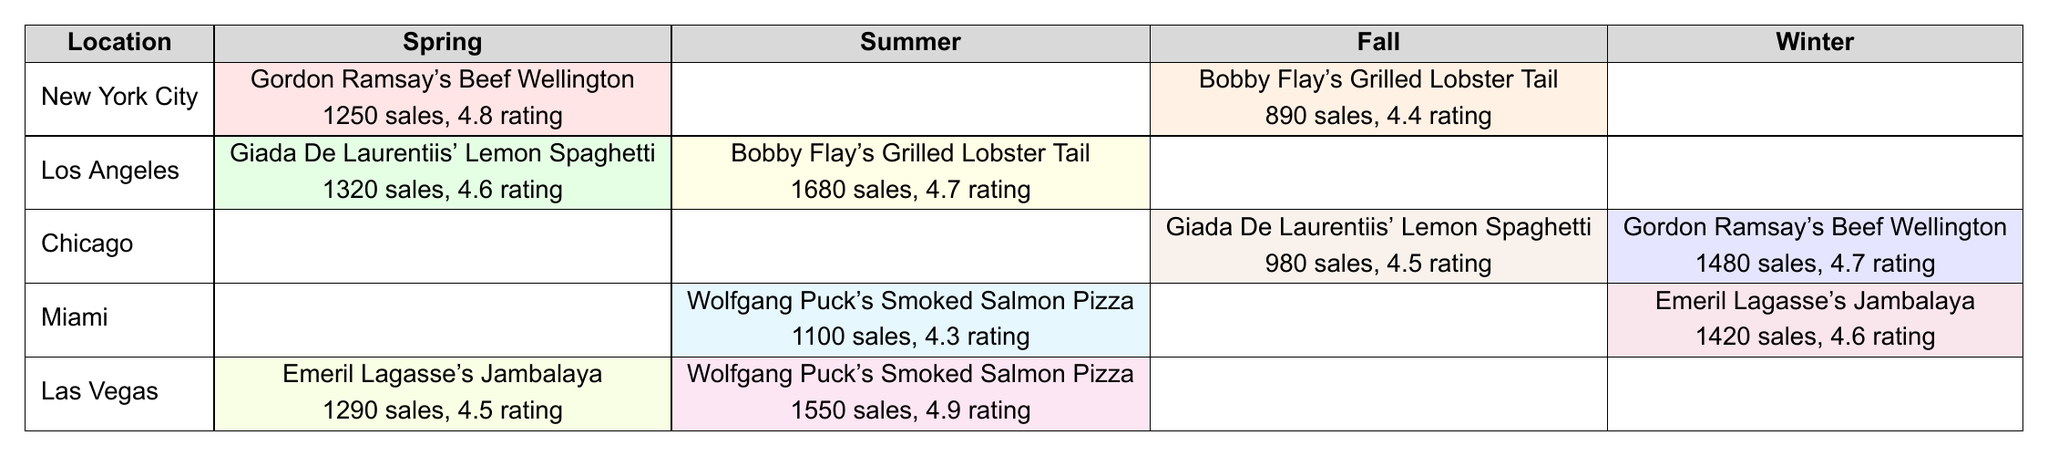What seasonal menu item had the highest sales in New York City? In the table, the seasonal menu item with the highest sales in New York City is Gordon Ramsay's Beef Wellington during Spring, with sales of 1250.
Answer: Gordon Ramsay's Beef Wellington Which item had the lowest rating across all locations? Looking at the ratings in the table, the item with the lowest rating is Wolfgang Puck's Smoked Salmon Pizza in Miami during Summer, with a rating of 4.3.
Answer: Wolfgang Puck's Smoked Salmon Pizza What is the average sales figure for all menu items in Summer? Summing the sales for Summer: 1680 (Bobby Flay's in Los Angeles) + 1550 (Wolfgang Puck's in Las Vegas) + 1100 (Wolfgang Puck's in Miami) gives 4330. There are 3 menu items, so the average is 4330/3 = 1443.33.
Answer: 1443.33 Did any item in Winter outperform its Spring counterpart in terms of sales? Comparing data from Winter and Spring: In Chicago, Gordon Ramsay's Beef Wellington in Winter achieved sales of 1480, which is greater than Gordon Ramsay's Beef Wellington in Spring with 1250 sales in New York City. Also, Emeril Lagasse's Jambalaya in Miami (1420 sales) outperformed the Spring sales of any other item.
Answer: Yes Which location had the best-rated item across all seasons? The best-rated item is Wolfgang Puck's Smoked Salmon Pizza in Las Vegas during Summer, with a rating of 4.9, which is the highest across all locations and seasons.
Answer: Las Vegas What is the combined sales total for Giada De Laurentiis' Lemon Spaghetti in Spring and Fall? In the Spring in Los Angeles, Giada's Lemon Spaghetti sold 1320, and in the Fall in Chicago, it sold 980. Adding those gives a combined total of 1320 + 980 = 2300.
Answer: 2300 In which season did Miami feature the most popular menu item by rating? In Winter, Emeril Lagasse's Jambalaya had a rating of 4.6 which is the highest for Miami compared to Summer's Wolfgang Puck's Smoked Salmon Pizza with a rating of 4.3.
Answer: Winter Which celebrity chef's dish had the highest sales overall? The highest sales item overall is Bobby Flay's Grilled Lobster Tail in Los Angeles during Summer, with sales of 1680.
Answer: Bobby Flay How does the performance of sales in Los Angeles compare between Spring and Summer? In Spring, Los Angeles had sales of 1320 for Giada's Lemon Spaghetti, while in Summer it had sales of 1680 for Bobby's Lobster Tail. Summer outperformed Spring in terms of sales.
Answer: Summer outperformed Spring Is there a location with a notable consistency in sales across seasons? Yes, looking at Chicago, the sales have some consistency: 980 for Giada's Lemon Spaghetti in Fall and 1480 for Ramsay's Beef Wellington in Winter show better continuity than other locations, as they do not drop below 900.
Answer: Yes 